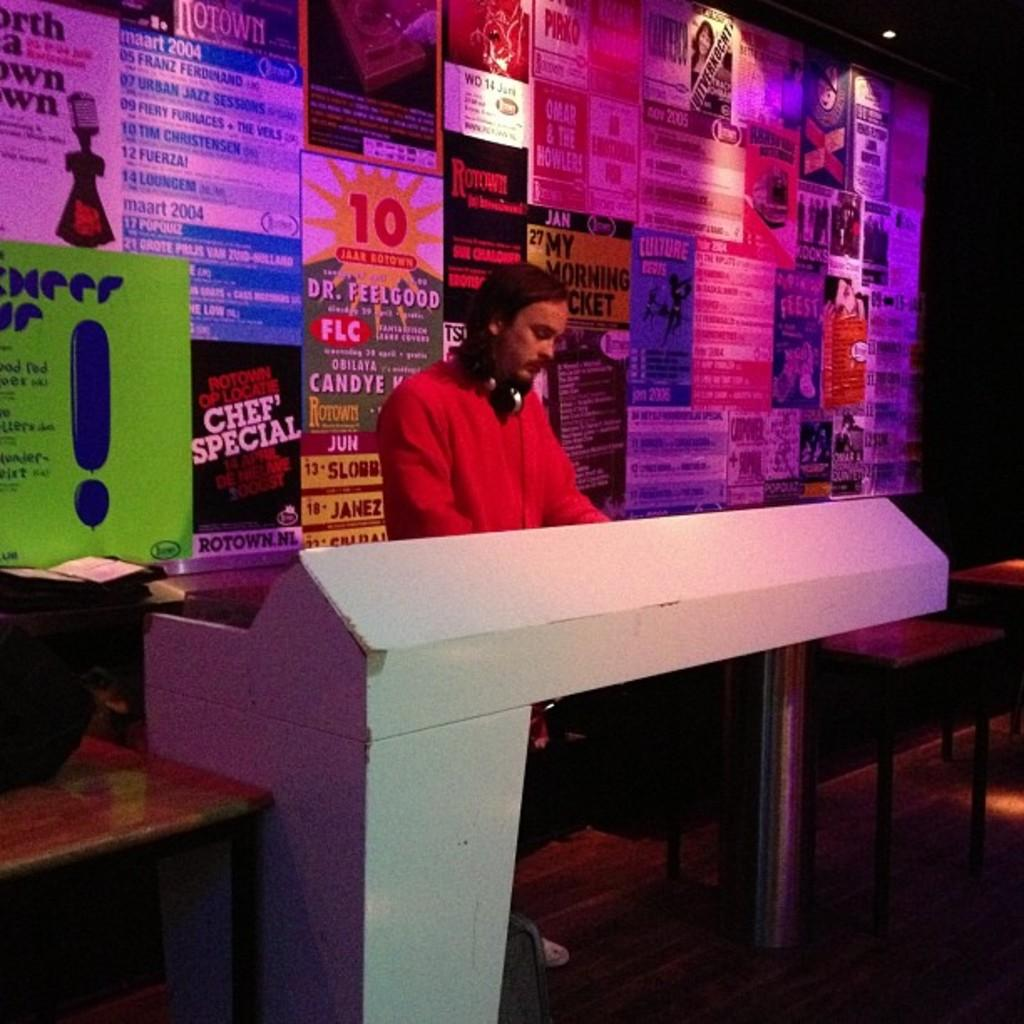<image>
Summarize the visual content of the image. A young man stands at a counter in front of posters for Chef Special, My Morning Jacket and Dr. Feelgood. 